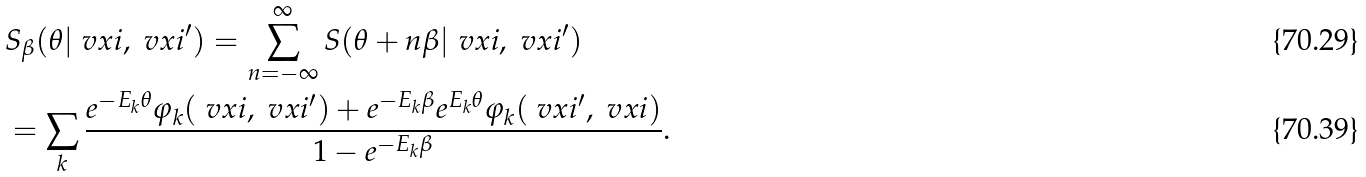Convert formula to latex. <formula><loc_0><loc_0><loc_500><loc_500>& S _ { \beta } ( \theta | \ v x i , \ v x i ^ { \prime } ) = \sum _ { n = - \infty } ^ { \infty } S ( \theta + n \beta | \ v x i , \ v x i ^ { \prime } ) \\ & = \sum _ { k } \frac { e ^ { - E _ { k } \theta } \varphi _ { k } ( \ v x i , \ v x i ^ { \prime } ) + e ^ { - E _ { k } \beta } e ^ { E _ { k } \theta } \varphi _ { k } ( \ v x i ^ { \prime } , \ v x i ) } { 1 - e ^ { - E _ { k } \beta } } .</formula> 